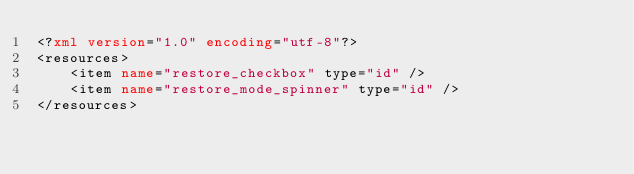<code> <loc_0><loc_0><loc_500><loc_500><_XML_><?xml version="1.0" encoding="utf-8"?>
<resources>
    <item name="restore_checkbox" type="id" />
    <item name="restore_mode_spinner" type="id" />
</resources></code> 